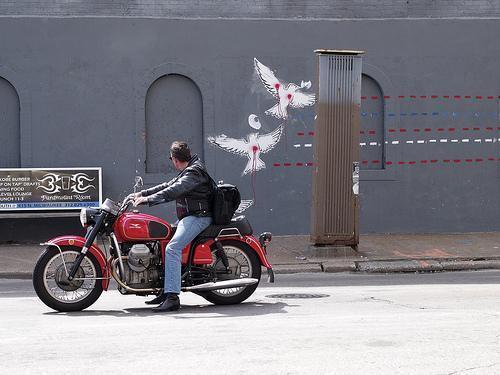How many people are in this image?
Give a very brief answer. 1. 